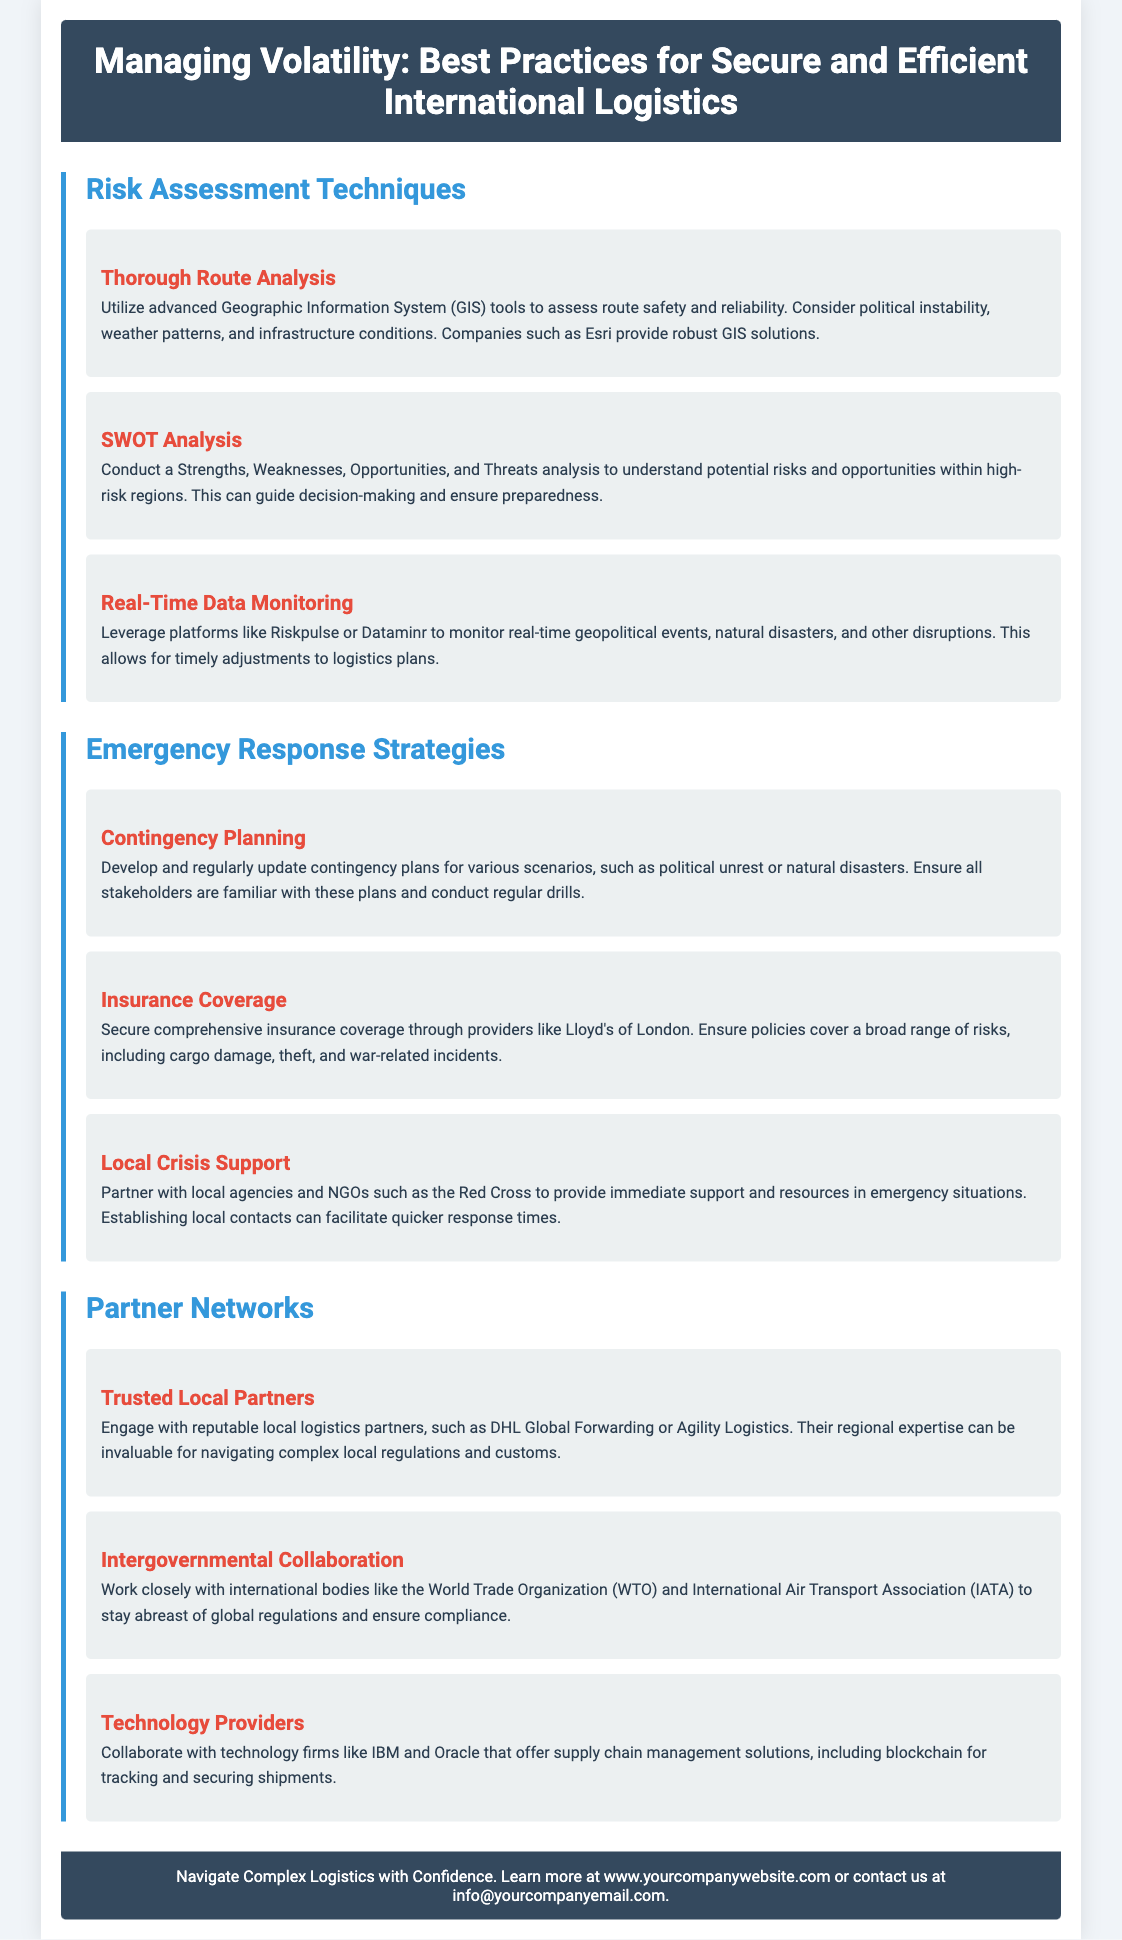what is the main focus of the flyer? The flyer details best practices for secure and efficient international logistics in volatile regions.
Answer: managing volatility which company provides robust GIS solutions? Esri is mentioned in the document as a provider of GIS solutions for route safety assessment.
Answer: Esri what type of analysis helps understand potential risks? The flyer mentions conducting a SWOT analysis as a technique for understanding risks and opportunities.
Answer: SWOT analysis which organization can provide immediate support in emergencies? The Red Cross is listed as a local agency that can assist with immediate support during emergencies.
Answer: Red Cross what is one strategy for handling natural disasters? Developing and regularly updating contingency plans is advised for managing scenarios like natural disasters.
Answer: Contingency Planning which two organizations should be engaged for international collaboration? The World Trade Organization and the International Air Transport Association are suggested for intergovernmental collaboration.
Answer: WTO and IATA what type of firms should be collaborated with for supply chain management solutions? Collaborating with technology firms, specifically mentioned are IBM and Oracle for supply chain solutions.
Answer: IBM and Oracle how often should contingency plans be updated? Regular updates to contingency plans are recommended in the document.
Answer: regularly what is the goal of the flyer? To provide best practices for secure logistics in high-risk regions is the intended goal of the flyer.
Answer: best practices 